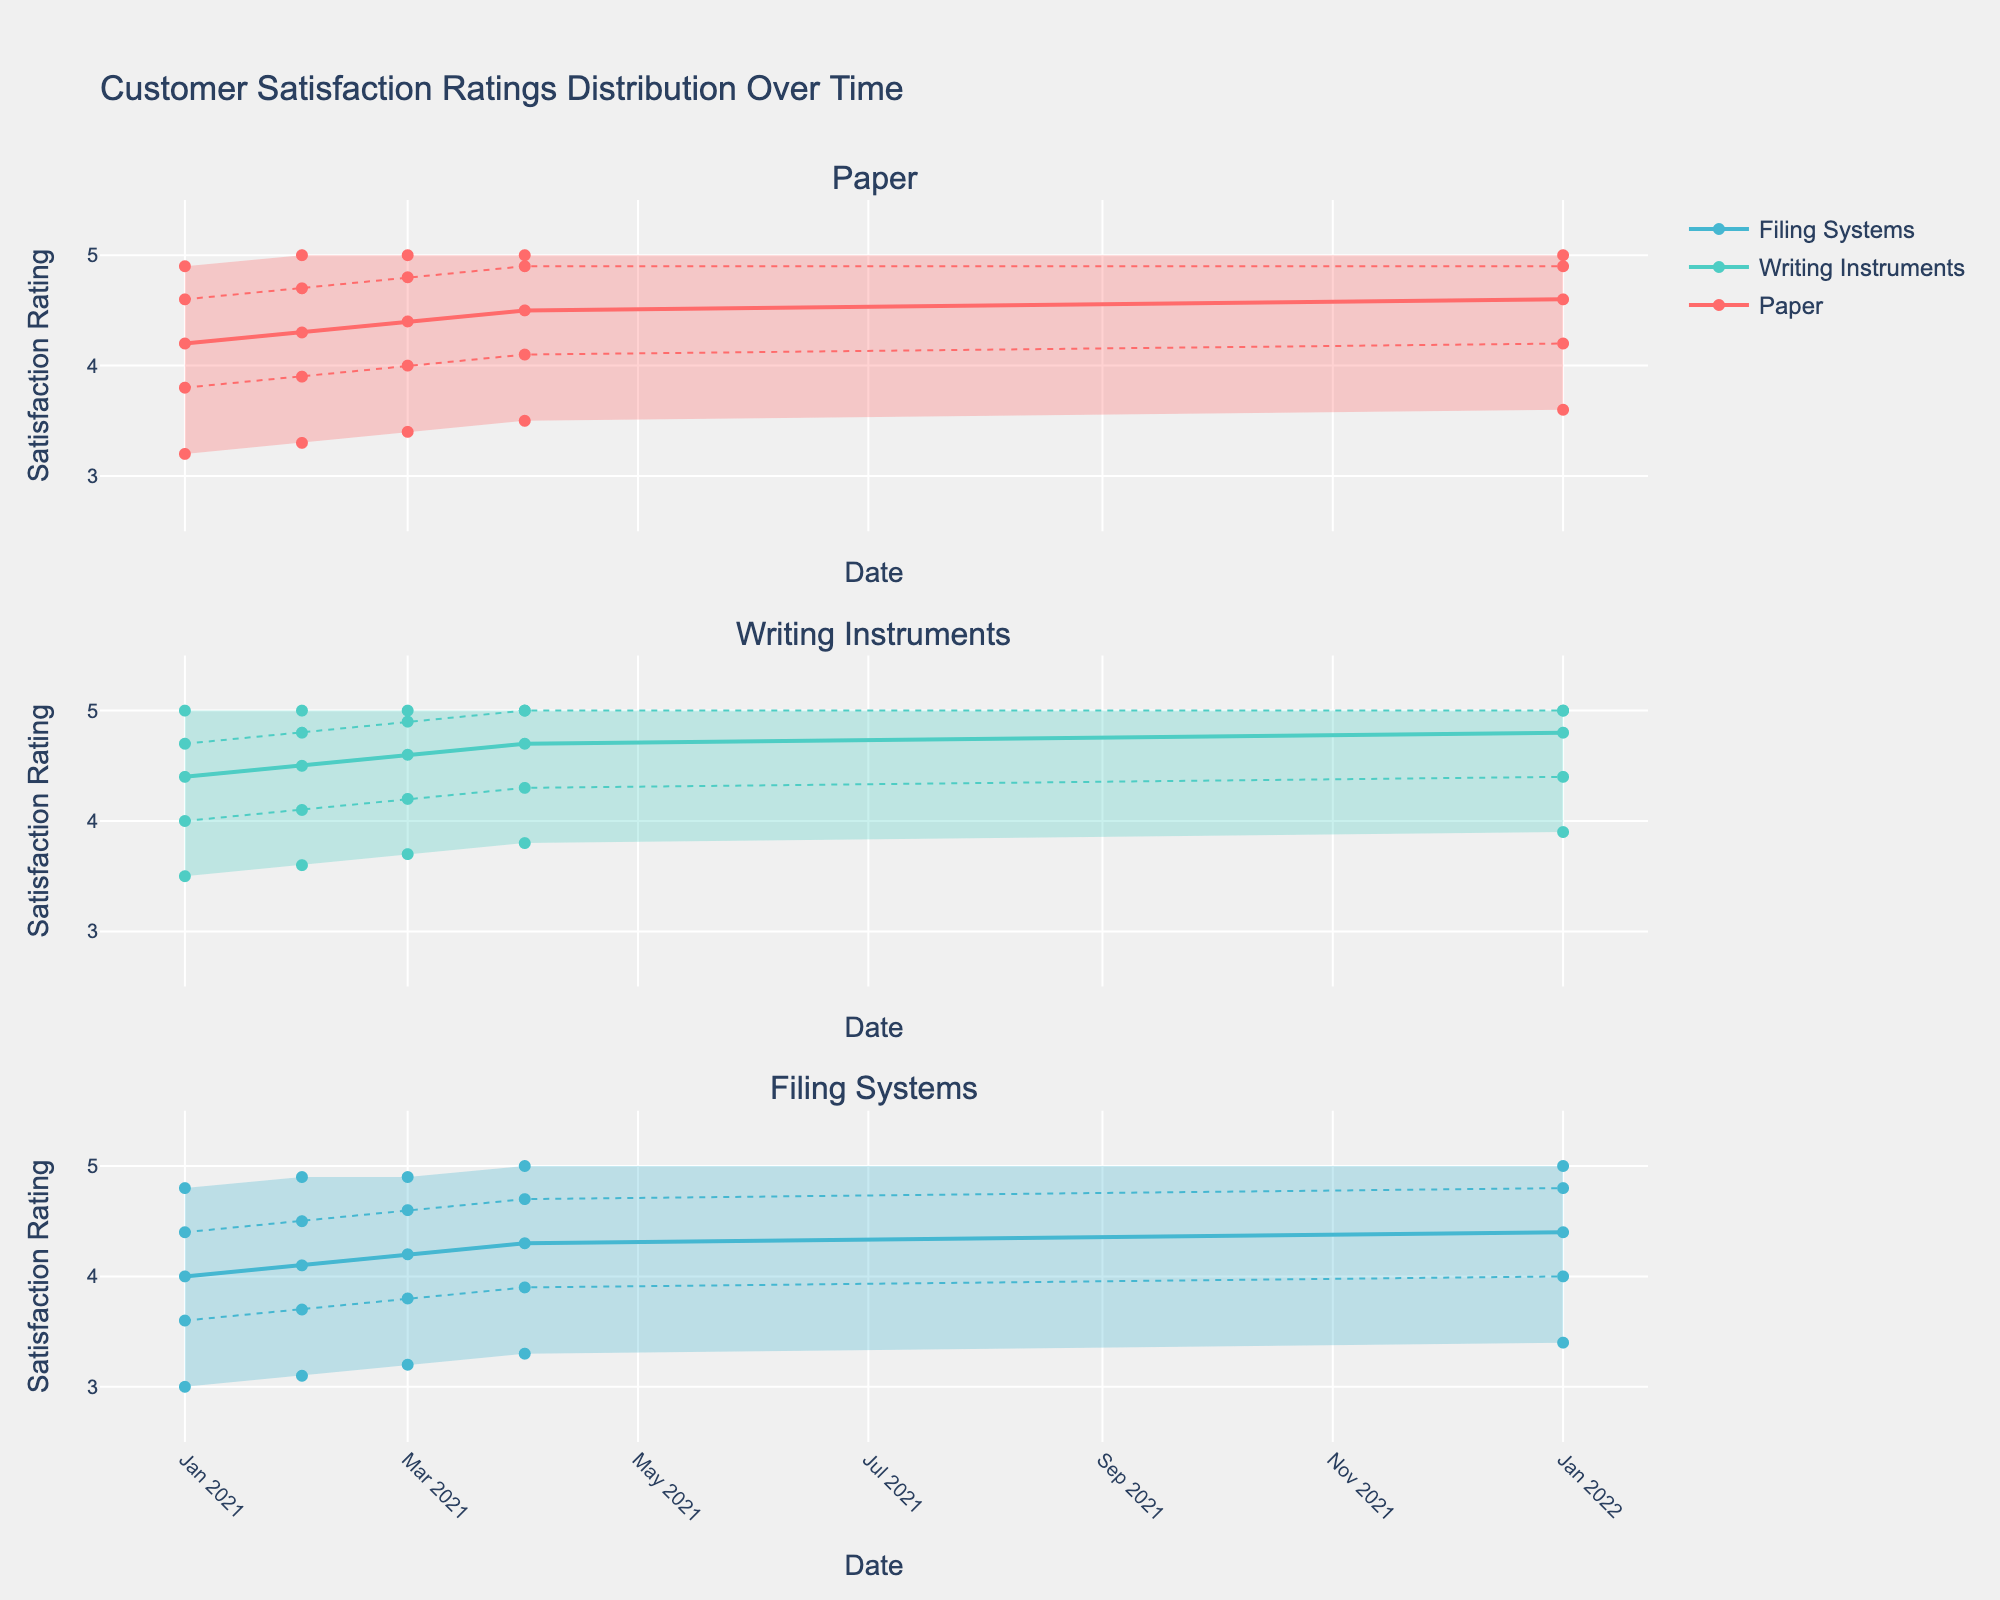What's the title of the chart? The title can be found at the top of the chart, which usually describes what the chart is about. In this case, the title is "Customer Satisfaction Ratings Distribution Over Time".
Answer: Customer Satisfaction Ratings Distribution Over Time How many product types are shown in the chart? The chart includes subplots with titles for each product type. By counting these titles, we can see there are three product types.
Answer: Three Which product type has the highest median satisfaction rating in Q1 2022? Look at the median lines (thicker lines) for each product type in Q1 2022 and identify the highest value. The products are "Paper", "Writing Instruments", and "Filing Systems". The highest median satisfaction rating is for "Writing Instruments".
Answer: Writing Instruments During which quarter did the "Paper" product type reach a median satisfaction rating of 4.5? The "Paper" subplot will have a thick line representing the median. Locate the point where this line intersects with 4.5 on the Y-axis and note the corresponding X-axis value (quarter and year).
Answer: Q4 2021 Compare the median ratings of "Writing Instruments" and "Filing Systems" in Q3 2021. Look at the thick lines (medians) for both "Writing Instruments" and "Filing Systems" in Q3 2021 and compare their values. "Writing Instruments" has a median of 4.6, while "Filing Systems" has 4.2.
Answer: Writing Instruments has a higher median What is the range between the 90th and the 10th percentiles for "Paper" in Q2 2021? The range can be calculated by subtracting the 10th percentile from the 90th percentile values for "Paper" in Q2 2021. The values are 5.0 for the 90th and 3.3 for the 10th percentile. The range is 5.0 - 3.3.
Answer: 1.7 How has the median satisfaction rating for "Filing Systems" changed over 2021? Look at the trend of the thick line (median) in the "Filing Systems" subplot across all quarters in 2021. It starts at 4.0 in Q1, goes to 4.1 in Q2, to 4.2 in Q3, and finally to 4.3 in Q4.
Answer: It has consistently increased Which product type shows the steepest improvement in median rating from Q1 2021 to Q1 2022? Identify the product type with the largest positive change in its median line from Q1 2021 to Q1 2022. "Paper" improved from 4.2 to 4.6 (+0.4), "Writing Instruments" from 4.4 to 4.8 (+0.4), and "Filing Systems" from 4.0 to 4.4 (+0.4). Since all show the same improvement, there is no single steepest line.
Answer: All three products show equal improvement In which quarter did "Writing Instruments" first reach a 90th percentile rating of 5.0? Look for the point where the upper boundary line (90th percentile) for "Writing Instruments" reaches 5.0 and note the corresponding quarter and year. This occurs in Q1 2021.
Answer: Q1 2021 